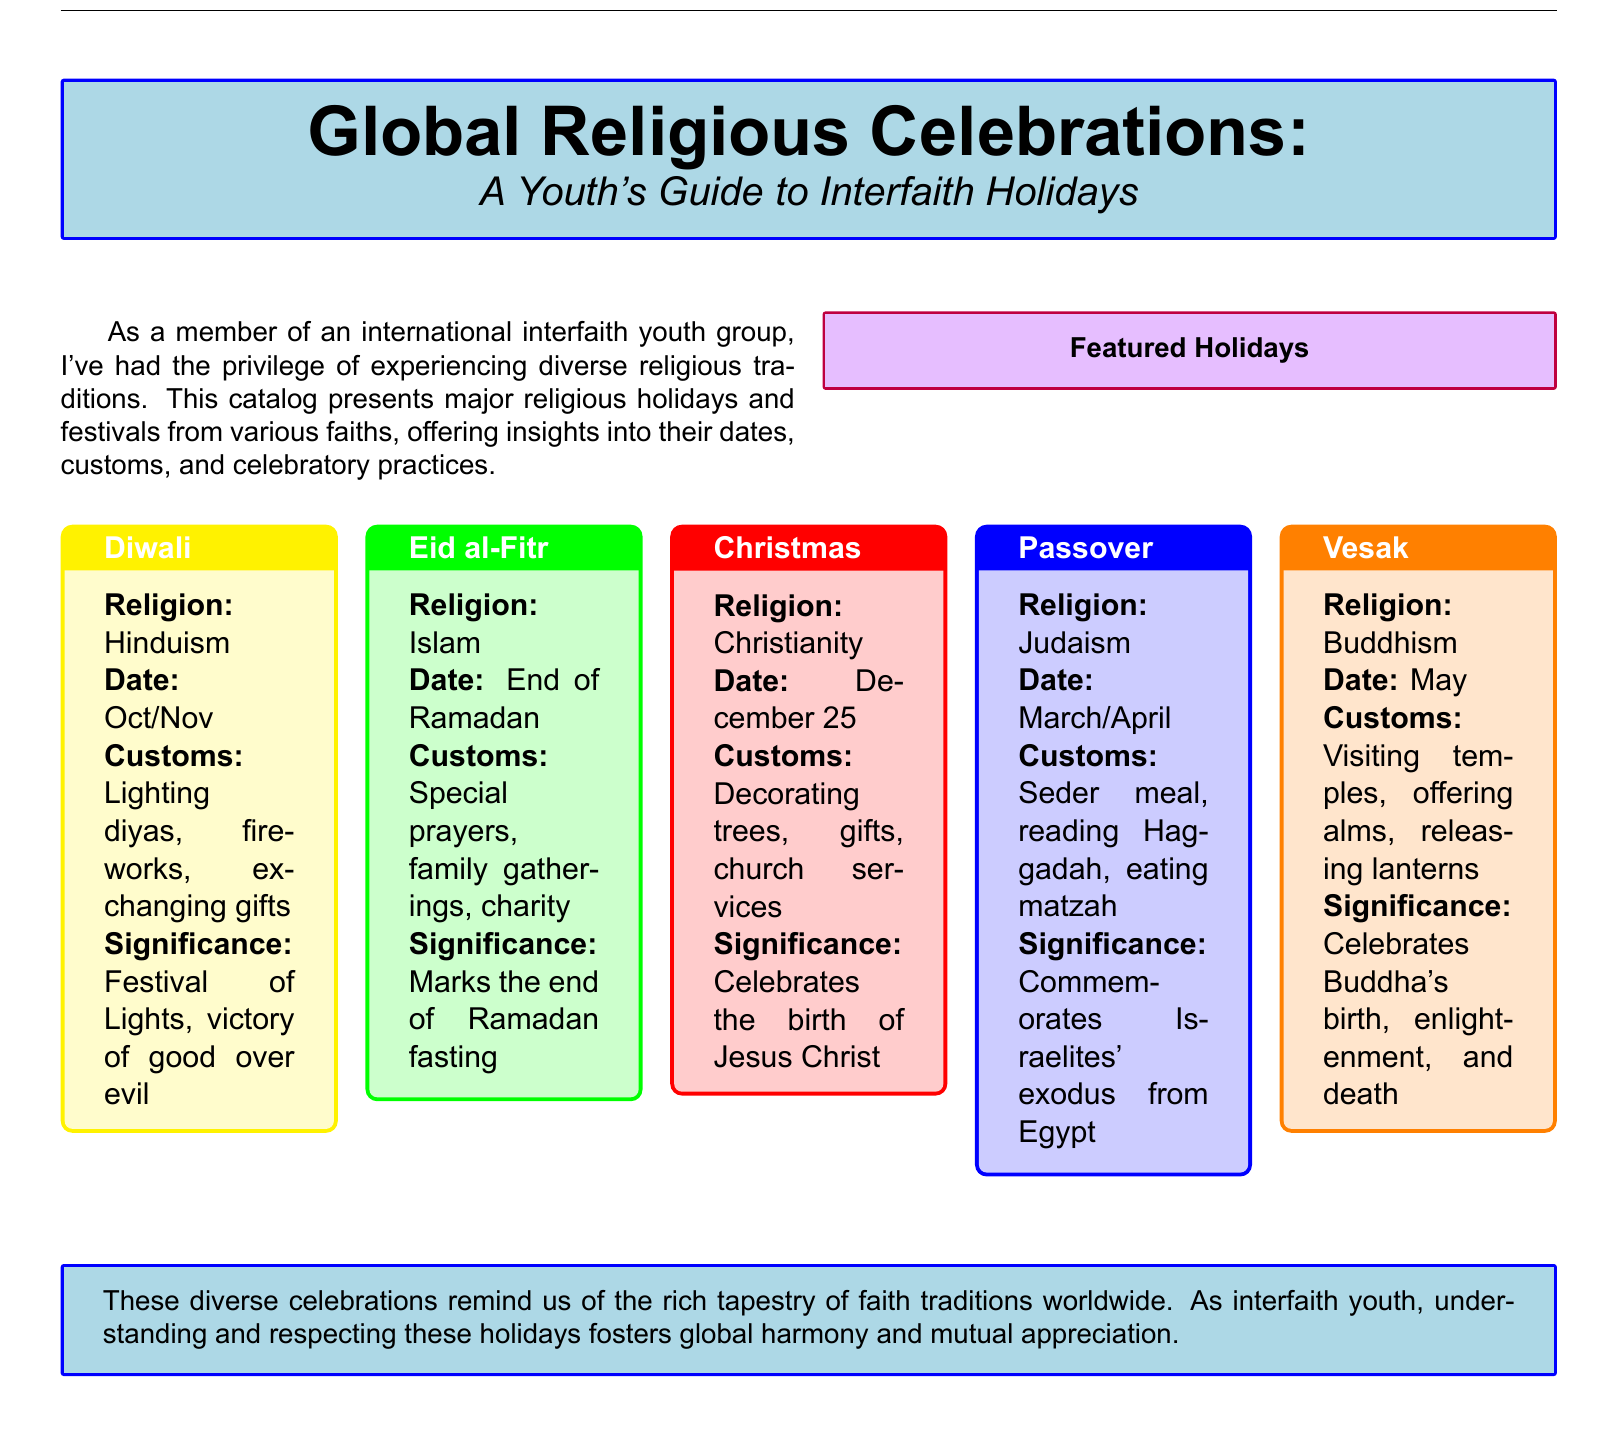What is the date of Eid al-Fitr? The document states that Eid al-Fitr occurs at the end of Ramadan.
Answer: End of Ramadan What is the significance of Diwali? The significance of Diwali is explained as the Festival of Lights, signifying the victory of good over evil.
Answer: Festival of Lights, victory of good over evil What are the customs observed during Christmas? The document lists decorating trees, gifts, and church services as customs for Christmas.
Answer: Decorating trees, gifts, church services In which month is Vesak celebrated? The document indicates that Vesak is celebrated in May.
Answer: May What meal is part of the Passover customs? The document mentions the Seder meal as part of the customs for Passover.
Answer: Seder meal Which religion observes Diwali? The document lists Hinduism as the religion that observes Diwali.
Answer: Hinduism How many major holidays are featured in this document? The document showcases five major holidays.
Answer: Five What practice is common during Eid al-Fitr? The document states that special prayers are a common practice during Eid al-Fitr.
Answer: Special prayers What does the catalog aim to promote among interfaith youth? The document states that understanding and respecting these holidays fosters global harmony.
Answer: Global harmony 